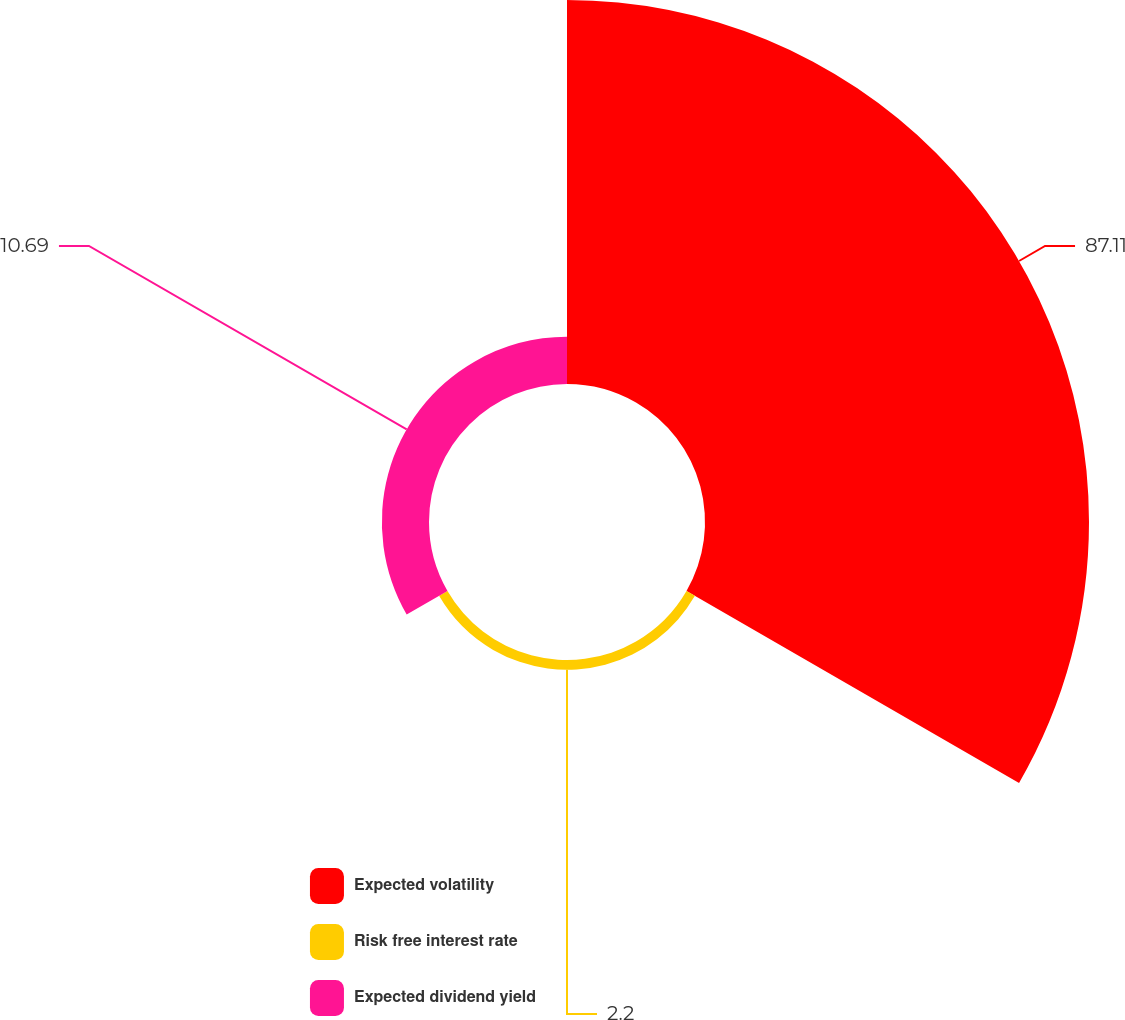Convert chart to OTSL. <chart><loc_0><loc_0><loc_500><loc_500><pie_chart><fcel>Expected volatility<fcel>Risk free interest rate<fcel>Expected dividend yield<nl><fcel>87.1%<fcel>2.2%<fcel>10.69%<nl></chart> 